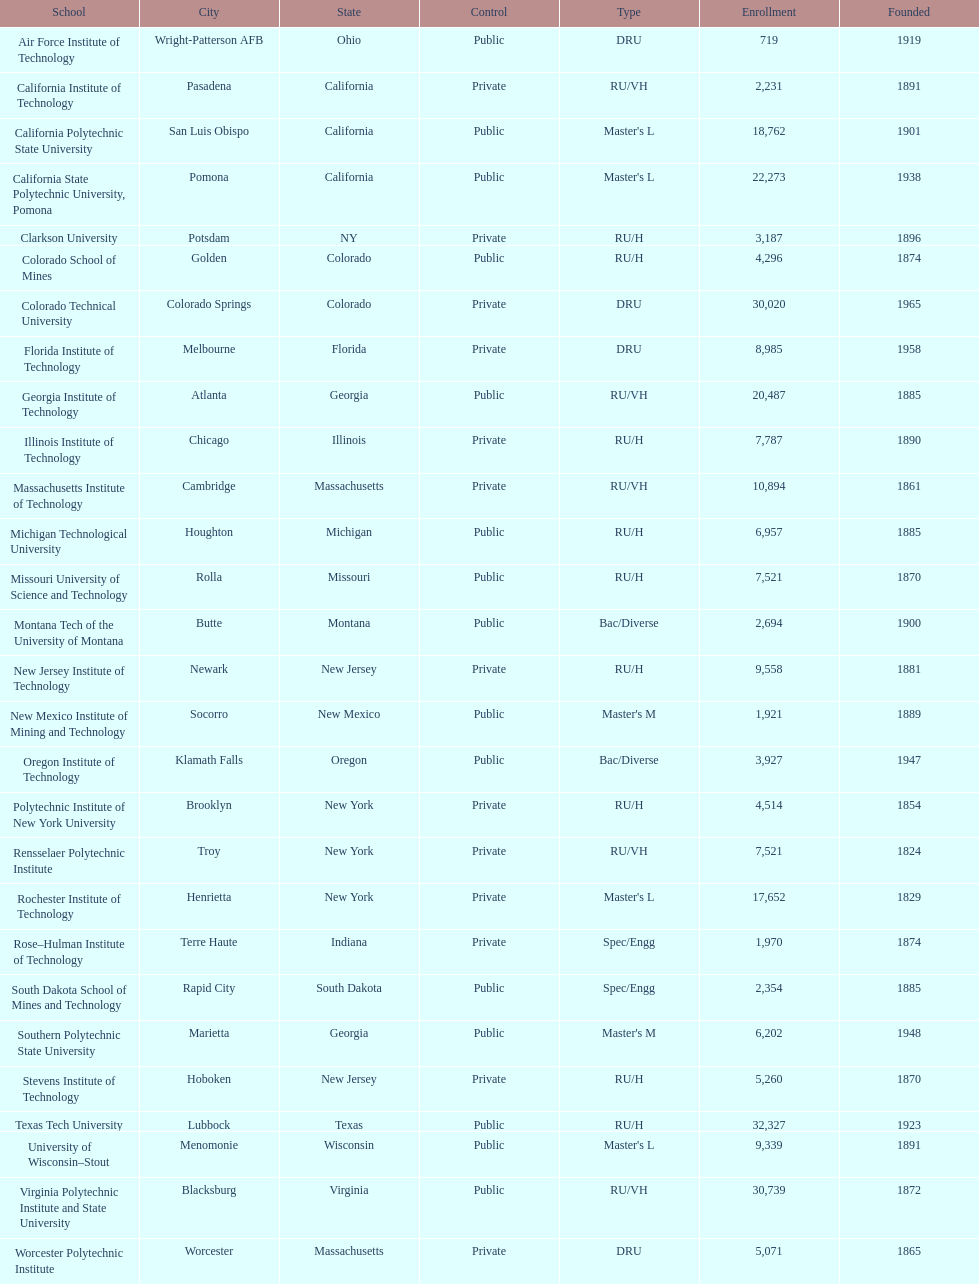Which school had the largest enrollment? Texas Tech University. 